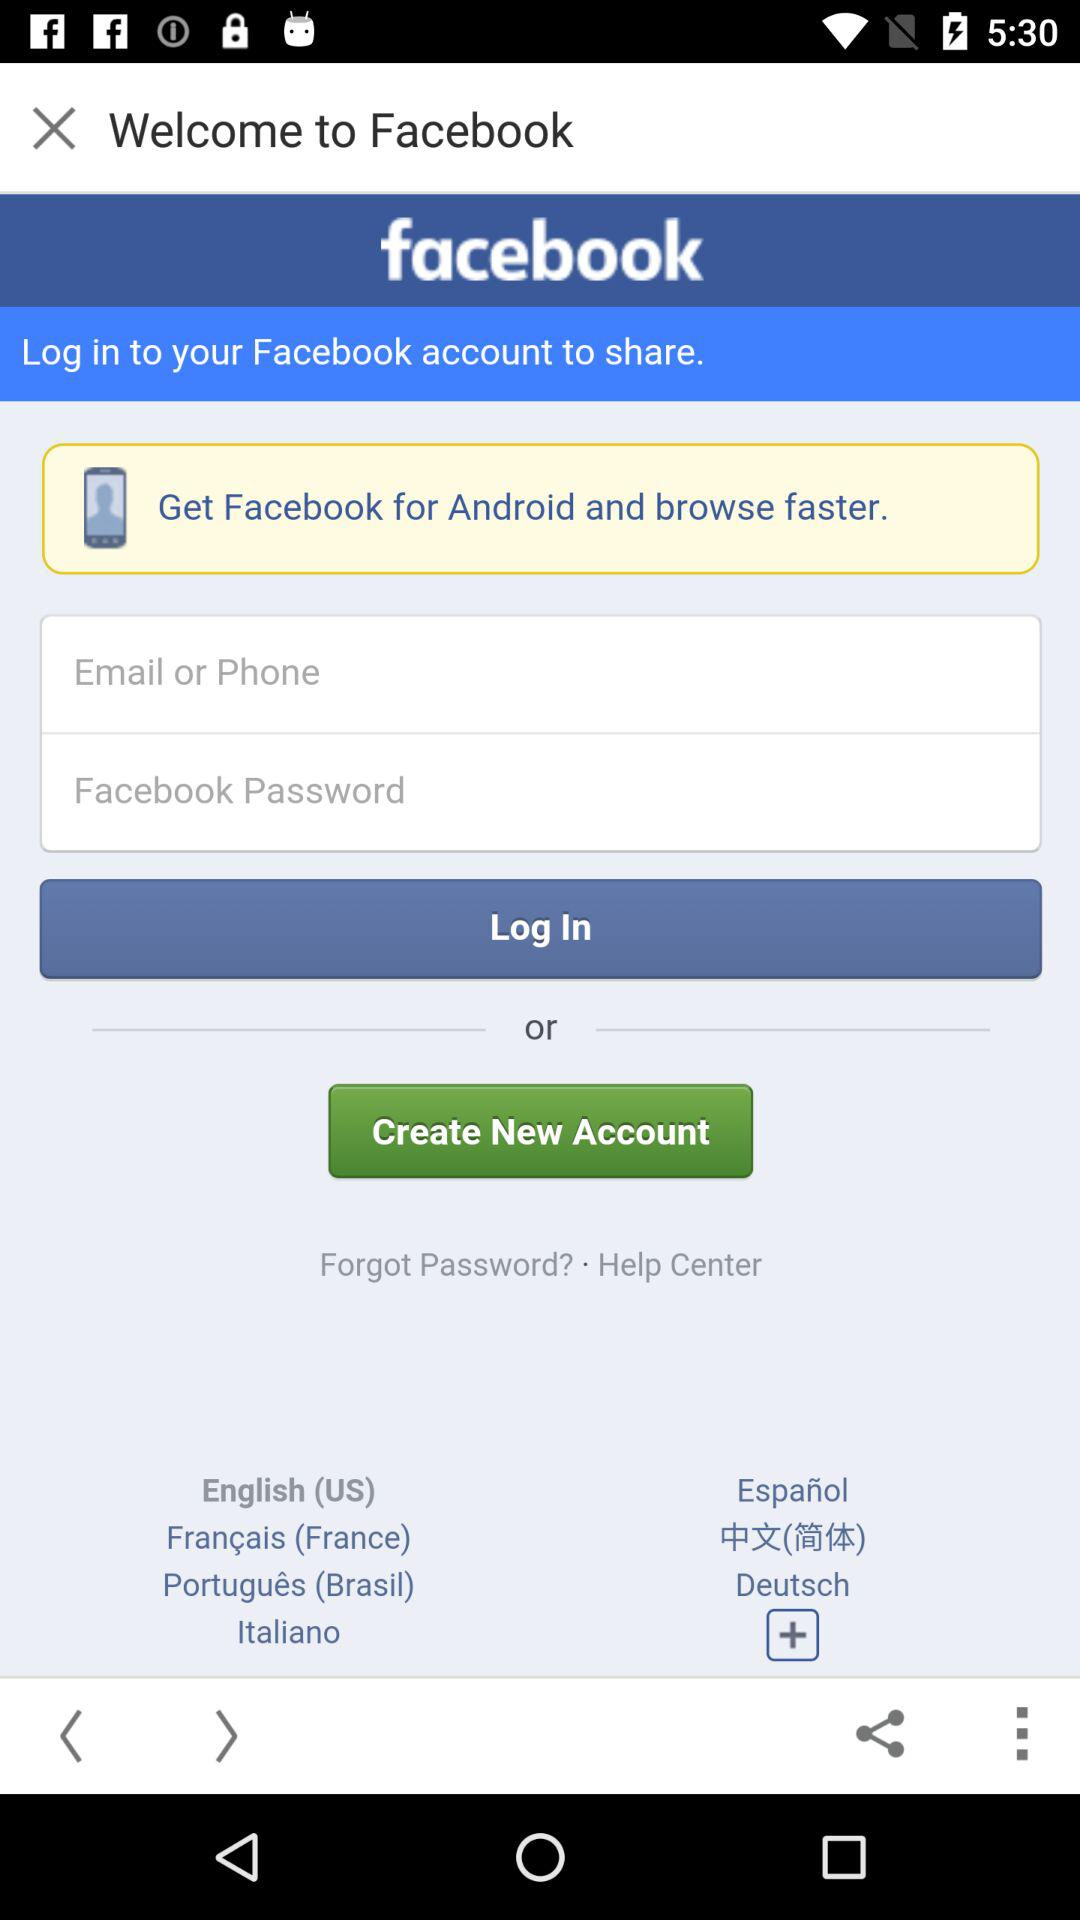How many input fields are there for logging in?
Answer the question using a single word or phrase. 2 